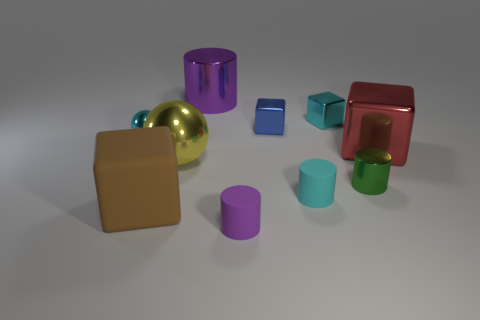The shiny block that is the same size as the blue thing is what color?
Your response must be concise. Cyan. Is there a small object that is left of the purple object to the left of the purple cylinder in front of the big cylinder?
Your answer should be compact. Yes. How big is the blue metallic block?
Give a very brief answer. Small. What number of objects are either small rubber cylinders or small green cylinders?
Your answer should be compact. 3. What is the color of the other big cube that is made of the same material as the blue block?
Make the answer very short. Red. There is a small metal thing that is left of the purple matte object; is its shape the same as the large yellow metallic object?
Make the answer very short. Yes. What number of objects are metallic things on the right side of the purple metal cylinder or tiny cylinders in front of the cyan cylinder?
Provide a succinct answer. 5. What is the color of the other large thing that is the same shape as the red shiny thing?
Your answer should be very brief. Brown. Do the red shiny thing and the small cyan thing on the left side of the small cyan matte cylinder have the same shape?
Your answer should be very brief. No. What is the material of the small cyan cylinder?
Offer a terse response. Rubber. 